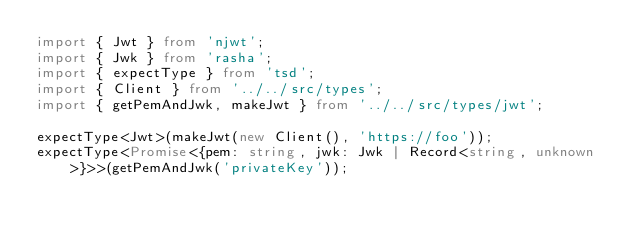<code> <loc_0><loc_0><loc_500><loc_500><_TypeScript_>import { Jwt } from 'njwt';
import { Jwk } from 'rasha';
import { expectType } from 'tsd';
import { Client } from '../../src/types';
import { getPemAndJwk, makeJwt } from '../../src/types/jwt';

expectType<Jwt>(makeJwt(new Client(), 'https://foo'));
expectType<Promise<{pem: string, jwk: Jwk | Record<string, unknown>}>>(getPemAndJwk('privateKey'));
</code> 